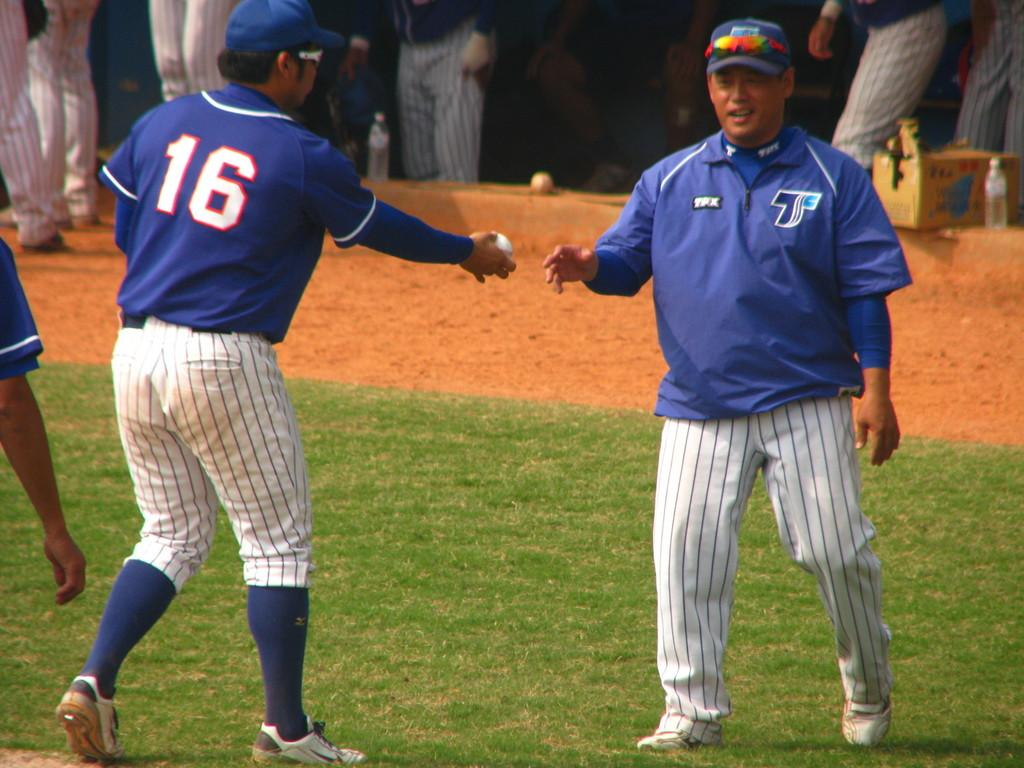<image>
Provide a brief description of the given image. a man with the letter T on the side of his jacket 